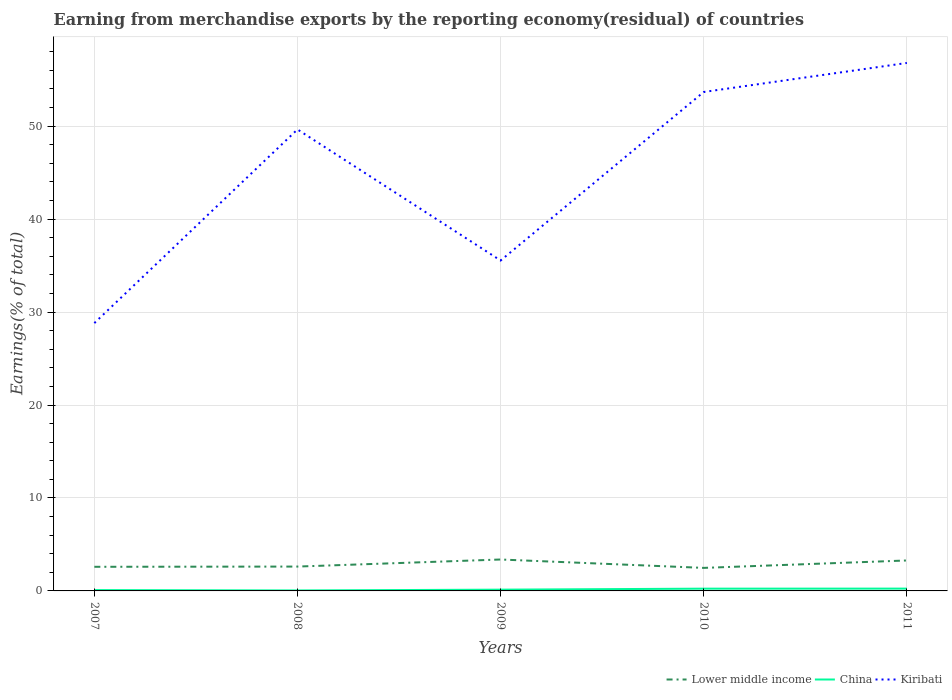How many different coloured lines are there?
Ensure brevity in your answer.  3. Is the number of lines equal to the number of legend labels?
Keep it short and to the point. Yes. Across all years, what is the maximum percentage of amount earned from merchandise exports in Lower middle income?
Provide a short and direct response. 2.48. In which year was the percentage of amount earned from merchandise exports in Lower middle income maximum?
Ensure brevity in your answer.  2010. What is the total percentage of amount earned from merchandise exports in Lower middle income in the graph?
Your answer should be compact. -0.79. What is the difference between the highest and the second highest percentage of amount earned from merchandise exports in China?
Provide a short and direct response. 0.2. What is the difference between the highest and the lowest percentage of amount earned from merchandise exports in Kiribati?
Provide a short and direct response. 3. Is the percentage of amount earned from merchandise exports in Lower middle income strictly greater than the percentage of amount earned from merchandise exports in Kiribati over the years?
Ensure brevity in your answer.  Yes. How many lines are there?
Keep it short and to the point. 3. How many years are there in the graph?
Give a very brief answer. 5. What is the difference between two consecutive major ticks on the Y-axis?
Give a very brief answer. 10. Where does the legend appear in the graph?
Your answer should be compact. Bottom right. How many legend labels are there?
Your answer should be compact. 3. How are the legend labels stacked?
Your response must be concise. Horizontal. What is the title of the graph?
Make the answer very short. Earning from merchandise exports by the reporting economy(residual) of countries. Does "Switzerland" appear as one of the legend labels in the graph?
Your response must be concise. No. What is the label or title of the X-axis?
Give a very brief answer. Years. What is the label or title of the Y-axis?
Give a very brief answer. Earnings(% of total). What is the Earnings(% of total) of Lower middle income in 2007?
Keep it short and to the point. 2.6. What is the Earnings(% of total) in China in 2007?
Provide a succinct answer. 0.09. What is the Earnings(% of total) in Kiribati in 2007?
Ensure brevity in your answer.  28.81. What is the Earnings(% of total) in Lower middle income in 2008?
Provide a short and direct response. 2.62. What is the Earnings(% of total) in China in 2008?
Ensure brevity in your answer.  0.05. What is the Earnings(% of total) in Kiribati in 2008?
Provide a succinct answer. 49.65. What is the Earnings(% of total) of Lower middle income in 2009?
Give a very brief answer. 3.38. What is the Earnings(% of total) in China in 2009?
Ensure brevity in your answer.  0.14. What is the Earnings(% of total) of Kiribati in 2009?
Keep it short and to the point. 35.55. What is the Earnings(% of total) of Lower middle income in 2010?
Your answer should be very brief. 2.48. What is the Earnings(% of total) in China in 2010?
Provide a succinct answer. 0.24. What is the Earnings(% of total) of Kiribati in 2010?
Make the answer very short. 53.68. What is the Earnings(% of total) in Lower middle income in 2011?
Your answer should be compact. 3.28. What is the Earnings(% of total) in China in 2011?
Ensure brevity in your answer.  0.25. What is the Earnings(% of total) of Kiribati in 2011?
Your response must be concise. 56.8. Across all years, what is the maximum Earnings(% of total) in Lower middle income?
Provide a short and direct response. 3.38. Across all years, what is the maximum Earnings(% of total) in China?
Ensure brevity in your answer.  0.25. Across all years, what is the maximum Earnings(% of total) in Kiribati?
Your answer should be compact. 56.8. Across all years, what is the minimum Earnings(% of total) of Lower middle income?
Offer a terse response. 2.48. Across all years, what is the minimum Earnings(% of total) in China?
Your response must be concise. 0.05. Across all years, what is the minimum Earnings(% of total) in Kiribati?
Offer a terse response. 28.81. What is the total Earnings(% of total) in Lower middle income in the graph?
Your response must be concise. 14.35. What is the total Earnings(% of total) in China in the graph?
Provide a short and direct response. 0.77. What is the total Earnings(% of total) in Kiribati in the graph?
Provide a short and direct response. 224.49. What is the difference between the Earnings(% of total) in Lower middle income in 2007 and that in 2008?
Ensure brevity in your answer.  -0.03. What is the difference between the Earnings(% of total) in China in 2007 and that in 2008?
Provide a short and direct response. 0.04. What is the difference between the Earnings(% of total) in Kiribati in 2007 and that in 2008?
Provide a succinct answer. -20.84. What is the difference between the Earnings(% of total) of Lower middle income in 2007 and that in 2009?
Your answer should be compact. -0.79. What is the difference between the Earnings(% of total) in China in 2007 and that in 2009?
Provide a short and direct response. -0.05. What is the difference between the Earnings(% of total) of Kiribati in 2007 and that in 2009?
Offer a terse response. -6.73. What is the difference between the Earnings(% of total) of Lower middle income in 2007 and that in 2010?
Make the answer very short. 0.12. What is the difference between the Earnings(% of total) in China in 2007 and that in 2010?
Make the answer very short. -0.15. What is the difference between the Earnings(% of total) in Kiribati in 2007 and that in 2010?
Provide a succinct answer. -24.87. What is the difference between the Earnings(% of total) in Lower middle income in 2007 and that in 2011?
Offer a very short reply. -0.68. What is the difference between the Earnings(% of total) of China in 2007 and that in 2011?
Keep it short and to the point. -0.16. What is the difference between the Earnings(% of total) in Kiribati in 2007 and that in 2011?
Provide a succinct answer. -27.99. What is the difference between the Earnings(% of total) of Lower middle income in 2008 and that in 2009?
Ensure brevity in your answer.  -0.76. What is the difference between the Earnings(% of total) in China in 2008 and that in 2009?
Make the answer very short. -0.09. What is the difference between the Earnings(% of total) in Kiribati in 2008 and that in 2009?
Provide a short and direct response. 14.1. What is the difference between the Earnings(% of total) in Lower middle income in 2008 and that in 2010?
Your answer should be compact. 0.14. What is the difference between the Earnings(% of total) in China in 2008 and that in 2010?
Provide a short and direct response. -0.19. What is the difference between the Earnings(% of total) of Kiribati in 2008 and that in 2010?
Your answer should be compact. -4.03. What is the difference between the Earnings(% of total) of Lower middle income in 2008 and that in 2011?
Your response must be concise. -0.66. What is the difference between the Earnings(% of total) in China in 2008 and that in 2011?
Ensure brevity in your answer.  -0.2. What is the difference between the Earnings(% of total) of Kiribati in 2008 and that in 2011?
Offer a terse response. -7.15. What is the difference between the Earnings(% of total) of Lower middle income in 2009 and that in 2010?
Ensure brevity in your answer.  0.9. What is the difference between the Earnings(% of total) in China in 2009 and that in 2010?
Offer a terse response. -0.11. What is the difference between the Earnings(% of total) in Kiribati in 2009 and that in 2010?
Ensure brevity in your answer.  -18.13. What is the difference between the Earnings(% of total) of Lower middle income in 2009 and that in 2011?
Offer a terse response. 0.1. What is the difference between the Earnings(% of total) of China in 2009 and that in 2011?
Offer a very short reply. -0.11. What is the difference between the Earnings(% of total) in Kiribati in 2009 and that in 2011?
Keep it short and to the point. -21.25. What is the difference between the Earnings(% of total) of Lower middle income in 2010 and that in 2011?
Ensure brevity in your answer.  -0.8. What is the difference between the Earnings(% of total) of China in 2010 and that in 2011?
Your answer should be compact. -0.01. What is the difference between the Earnings(% of total) of Kiribati in 2010 and that in 2011?
Provide a short and direct response. -3.12. What is the difference between the Earnings(% of total) in Lower middle income in 2007 and the Earnings(% of total) in China in 2008?
Your response must be concise. 2.54. What is the difference between the Earnings(% of total) in Lower middle income in 2007 and the Earnings(% of total) in Kiribati in 2008?
Offer a terse response. -47.05. What is the difference between the Earnings(% of total) in China in 2007 and the Earnings(% of total) in Kiribati in 2008?
Give a very brief answer. -49.56. What is the difference between the Earnings(% of total) in Lower middle income in 2007 and the Earnings(% of total) in China in 2009?
Offer a terse response. 2.46. What is the difference between the Earnings(% of total) in Lower middle income in 2007 and the Earnings(% of total) in Kiribati in 2009?
Your response must be concise. -32.95. What is the difference between the Earnings(% of total) of China in 2007 and the Earnings(% of total) of Kiribati in 2009?
Keep it short and to the point. -35.46. What is the difference between the Earnings(% of total) in Lower middle income in 2007 and the Earnings(% of total) in China in 2010?
Provide a succinct answer. 2.35. What is the difference between the Earnings(% of total) of Lower middle income in 2007 and the Earnings(% of total) of Kiribati in 2010?
Keep it short and to the point. -51.09. What is the difference between the Earnings(% of total) in China in 2007 and the Earnings(% of total) in Kiribati in 2010?
Provide a short and direct response. -53.59. What is the difference between the Earnings(% of total) of Lower middle income in 2007 and the Earnings(% of total) of China in 2011?
Your answer should be very brief. 2.35. What is the difference between the Earnings(% of total) of Lower middle income in 2007 and the Earnings(% of total) of Kiribati in 2011?
Provide a succinct answer. -54.21. What is the difference between the Earnings(% of total) of China in 2007 and the Earnings(% of total) of Kiribati in 2011?
Provide a short and direct response. -56.71. What is the difference between the Earnings(% of total) in Lower middle income in 2008 and the Earnings(% of total) in China in 2009?
Make the answer very short. 2.48. What is the difference between the Earnings(% of total) in Lower middle income in 2008 and the Earnings(% of total) in Kiribati in 2009?
Keep it short and to the point. -32.93. What is the difference between the Earnings(% of total) in China in 2008 and the Earnings(% of total) in Kiribati in 2009?
Offer a terse response. -35.5. What is the difference between the Earnings(% of total) of Lower middle income in 2008 and the Earnings(% of total) of China in 2010?
Give a very brief answer. 2.38. What is the difference between the Earnings(% of total) in Lower middle income in 2008 and the Earnings(% of total) in Kiribati in 2010?
Make the answer very short. -51.06. What is the difference between the Earnings(% of total) in China in 2008 and the Earnings(% of total) in Kiribati in 2010?
Give a very brief answer. -53.63. What is the difference between the Earnings(% of total) of Lower middle income in 2008 and the Earnings(% of total) of China in 2011?
Provide a short and direct response. 2.37. What is the difference between the Earnings(% of total) of Lower middle income in 2008 and the Earnings(% of total) of Kiribati in 2011?
Ensure brevity in your answer.  -54.18. What is the difference between the Earnings(% of total) in China in 2008 and the Earnings(% of total) in Kiribati in 2011?
Provide a short and direct response. -56.75. What is the difference between the Earnings(% of total) of Lower middle income in 2009 and the Earnings(% of total) of China in 2010?
Offer a terse response. 3.14. What is the difference between the Earnings(% of total) in Lower middle income in 2009 and the Earnings(% of total) in Kiribati in 2010?
Your answer should be compact. -50.3. What is the difference between the Earnings(% of total) in China in 2009 and the Earnings(% of total) in Kiribati in 2010?
Provide a short and direct response. -53.54. What is the difference between the Earnings(% of total) of Lower middle income in 2009 and the Earnings(% of total) of China in 2011?
Provide a succinct answer. 3.13. What is the difference between the Earnings(% of total) of Lower middle income in 2009 and the Earnings(% of total) of Kiribati in 2011?
Your answer should be very brief. -53.42. What is the difference between the Earnings(% of total) in China in 2009 and the Earnings(% of total) in Kiribati in 2011?
Keep it short and to the point. -56.67. What is the difference between the Earnings(% of total) of Lower middle income in 2010 and the Earnings(% of total) of China in 2011?
Offer a very short reply. 2.23. What is the difference between the Earnings(% of total) in Lower middle income in 2010 and the Earnings(% of total) in Kiribati in 2011?
Your answer should be very brief. -54.32. What is the difference between the Earnings(% of total) in China in 2010 and the Earnings(% of total) in Kiribati in 2011?
Make the answer very short. -56.56. What is the average Earnings(% of total) in Lower middle income per year?
Your answer should be very brief. 2.87. What is the average Earnings(% of total) in China per year?
Offer a very short reply. 0.15. What is the average Earnings(% of total) in Kiribati per year?
Offer a very short reply. 44.9. In the year 2007, what is the difference between the Earnings(% of total) in Lower middle income and Earnings(% of total) in China?
Your answer should be compact. 2.5. In the year 2007, what is the difference between the Earnings(% of total) of Lower middle income and Earnings(% of total) of Kiribati?
Offer a very short reply. -26.22. In the year 2007, what is the difference between the Earnings(% of total) of China and Earnings(% of total) of Kiribati?
Make the answer very short. -28.72. In the year 2008, what is the difference between the Earnings(% of total) in Lower middle income and Earnings(% of total) in China?
Give a very brief answer. 2.57. In the year 2008, what is the difference between the Earnings(% of total) of Lower middle income and Earnings(% of total) of Kiribati?
Offer a terse response. -47.03. In the year 2008, what is the difference between the Earnings(% of total) of China and Earnings(% of total) of Kiribati?
Your answer should be compact. -49.6. In the year 2009, what is the difference between the Earnings(% of total) of Lower middle income and Earnings(% of total) of China?
Your answer should be compact. 3.24. In the year 2009, what is the difference between the Earnings(% of total) of Lower middle income and Earnings(% of total) of Kiribati?
Offer a terse response. -32.17. In the year 2009, what is the difference between the Earnings(% of total) of China and Earnings(% of total) of Kiribati?
Your answer should be compact. -35.41. In the year 2010, what is the difference between the Earnings(% of total) in Lower middle income and Earnings(% of total) in China?
Your response must be concise. 2.23. In the year 2010, what is the difference between the Earnings(% of total) of Lower middle income and Earnings(% of total) of Kiribati?
Ensure brevity in your answer.  -51.2. In the year 2010, what is the difference between the Earnings(% of total) in China and Earnings(% of total) in Kiribati?
Make the answer very short. -53.44. In the year 2011, what is the difference between the Earnings(% of total) of Lower middle income and Earnings(% of total) of China?
Keep it short and to the point. 3.03. In the year 2011, what is the difference between the Earnings(% of total) of Lower middle income and Earnings(% of total) of Kiribati?
Your answer should be compact. -53.53. In the year 2011, what is the difference between the Earnings(% of total) in China and Earnings(% of total) in Kiribati?
Your answer should be compact. -56.55. What is the ratio of the Earnings(% of total) in China in 2007 to that in 2008?
Your response must be concise. 1.77. What is the ratio of the Earnings(% of total) of Kiribati in 2007 to that in 2008?
Give a very brief answer. 0.58. What is the ratio of the Earnings(% of total) in Lower middle income in 2007 to that in 2009?
Your response must be concise. 0.77. What is the ratio of the Earnings(% of total) of China in 2007 to that in 2009?
Ensure brevity in your answer.  0.67. What is the ratio of the Earnings(% of total) in Kiribati in 2007 to that in 2009?
Keep it short and to the point. 0.81. What is the ratio of the Earnings(% of total) of Lower middle income in 2007 to that in 2010?
Keep it short and to the point. 1.05. What is the ratio of the Earnings(% of total) of China in 2007 to that in 2010?
Your answer should be compact. 0.37. What is the ratio of the Earnings(% of total) of Kiribati in 2007 to that in 2010?
Provide a short and direct response. 0.54. What is the ratio of the Earnings(% of total) in Lower middle income in 2007 to that in 2011?
Provide a short and direct response. 0.79. What is the ratio of the Earnings(% of total) in China in 2007 to that in 2011?
Give a very brief answer. 0.37. What is the ratio of the Earnings(% of total) of Kiribati in 2007 to that in 2011?
Your answer should be very brief. 0.51. What is the ratio of the Earnings(% of total) in Lower middle income in 2008 to that in 2009?
Offer a terse response. 0.78. What is the ratio of the Earnings(% of total) in China in 2008 to that in 2009?
Give a very brief answer. 0.38. What is the ratio of the Earnings(% of total) of Kiribati in 2008 to that in 2009?
Offer a terse response. 1.4. What is the ratio of the Earnings(% of total) of Lower middle income in 2008 to that in 2010?
Your answer should be compact. 1.06. What is the ratio of the Earnings(% of total) of China in 2008 to that in 2010?
Make the answer very short. 0.21. What is the ratio of the Earnings(% of total) of Kiribati in 2008 to that in 2010?
Make the answer very short. 0.92. What is the ratio of the Earnings(% of total) in Lower middle income in 2008 to that in 2011?
Your answer should be compact. 0.8. What is the ratio of the Earnings(% of total) in China in 2008 to that in 2011?
Offer a terse response. 0.21. What is the ratio of the Earnings(% of total) in Kiribati in 2008 to that in 2011?
Provide a succinct answer. 0.87. What is the ratio of the Earnings(% of total) in Lower middle income in 2009 to that in 2010?
Ensure brevity in your answer.  1.36. What is the ratio of the Earnings(% of total) in China in 2009 to that in 2010?
Give a very brief answer. 0.56. What is the ratio of the Earnings(% of total) in Kiribati in 2009 to that in 2010?
Make the answer very short. 0.66. What is the ratio of the Earnings(% of total) in Lower middle income in 2009 to that in 2011?
Your answer should be compact. 1.03. What is the ratio of the Earnings(% of total) of China in 2009 to that in 2011?
Offer a very short reply. 0.55. What is the ratio of the Earnings(% of total) of Kiribati in 2009 to that in 2011?
Provide a short and direct response. 0.63. What is the ratio of the Earnings(% of total) in Lower middle income in 2010 to that in 2011?
Give a very brief answer. 0.76. What is the ratio of the Earnings(% of total) of China in 2010 to that in 2011?
Your response must be concise. 0.98. What is the ratio of the Earnings(% of total) of Kiribati in 2010 to that in 2011?
Ensure brevity in your answer.  0.94. What is the difference between the highest and the second highest Earnings(% of total) of Lower middle income?
Ensure brevity in your answer.  0.1. What is the difference between the highest and the second highest Earnings(% of total) of China?
Give a very brief answer. 0.01. What is the difference between the highest and the second highest Earnings(% of total) of Kiribati?
Make the answer very short. 3.12. What is the difference between the highest and the lowest Earnings(% of total) in Lower middle income?
Offer a very short reply. 0.9. What is the difference between the highest and the lowest Earnings(% of total) of China?
Offer a terse response. 0.2. What is the difference between the highest and the lowest Earnings(% of total) in Kiribati?
Make the answer very short. 27.99. 